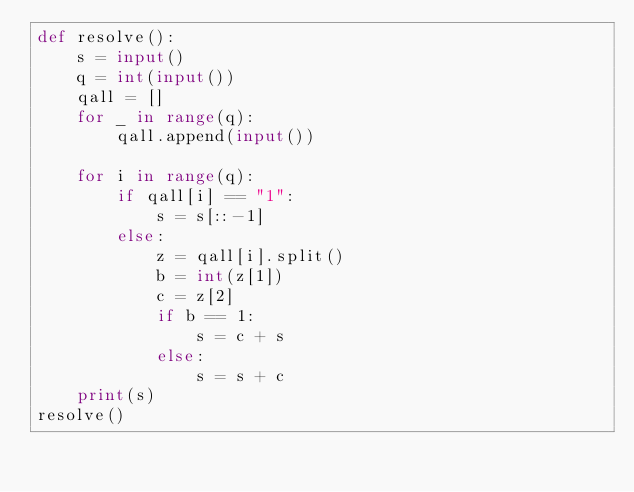<code> <loc_0><loc_0><loc_500><loc_500><_Python_>def resolve():
    s = input()
    q = int(input())
    qall = []
    for _ in range(q):
        qall.append(input())

    for i in range(q):
        if qall[i] == "1":
            s = s[::-1]
        else:
            z = qall[i].split()
            b = int(z[1])
            c = z[2]
            if b == 1:
                s = c + s
            else:
                s = s + c
    print(s)
resolve()</code> 